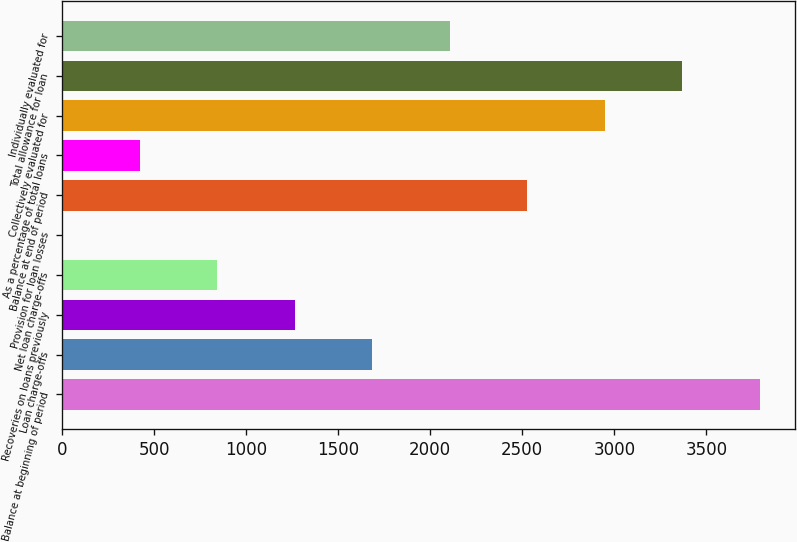Convert chart to OTSL. <chart><loc_0><loc_0><loc_500><loc_500><bar_chart><fcel>Balance at beginning of period<fcel>Loan charge-offs<fcel>Recoveries on loans previously<fcel>Net loan charge-offs<fcel>Provision for loan losses<fcel>Balance at end of period<fcel>As a percentage of total loans<fcel>Collectively evaluated for<fcel>Total allowance for loan<fcel>Individually evaluated for<nl><fcel>3791.8<fcel>1685.8<fcel>1264.6<fcel>843.4<fcel>1<fcel>2528.2<fcel>422.2<fcel>2949.4<fcel>3370.6<fcel>2107<nl></chart> 